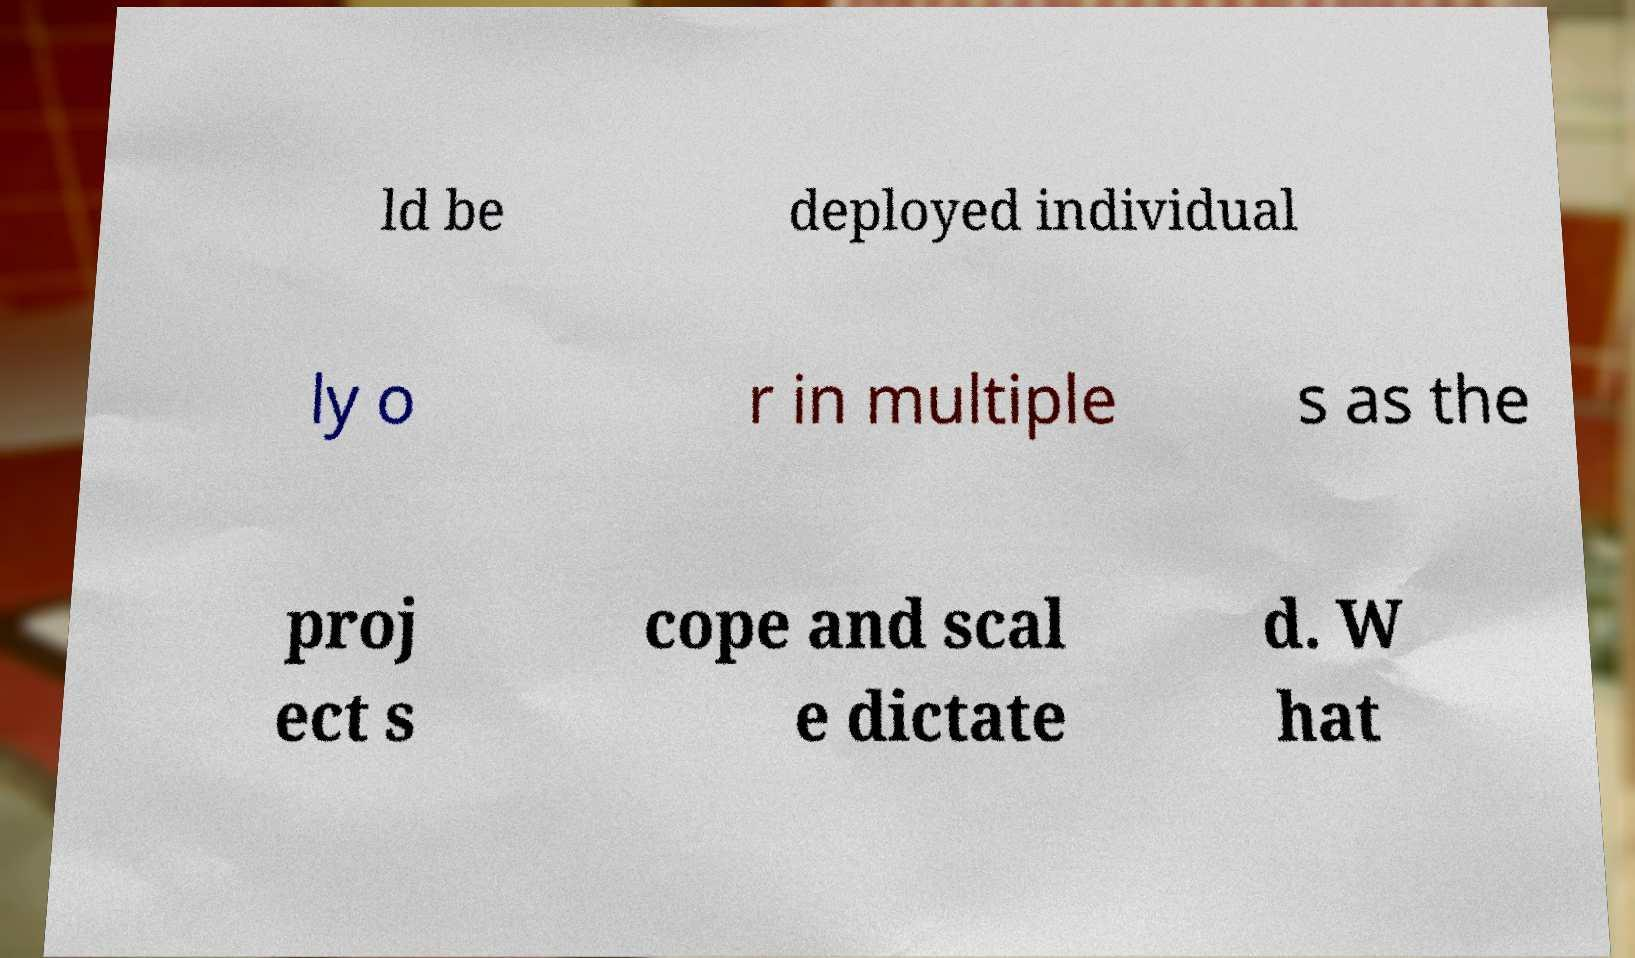Could you extract and type out the text from this image? ld be deployed individual ly o r in multiple s as the proj ect s cope and scal e dictate d. W hat 